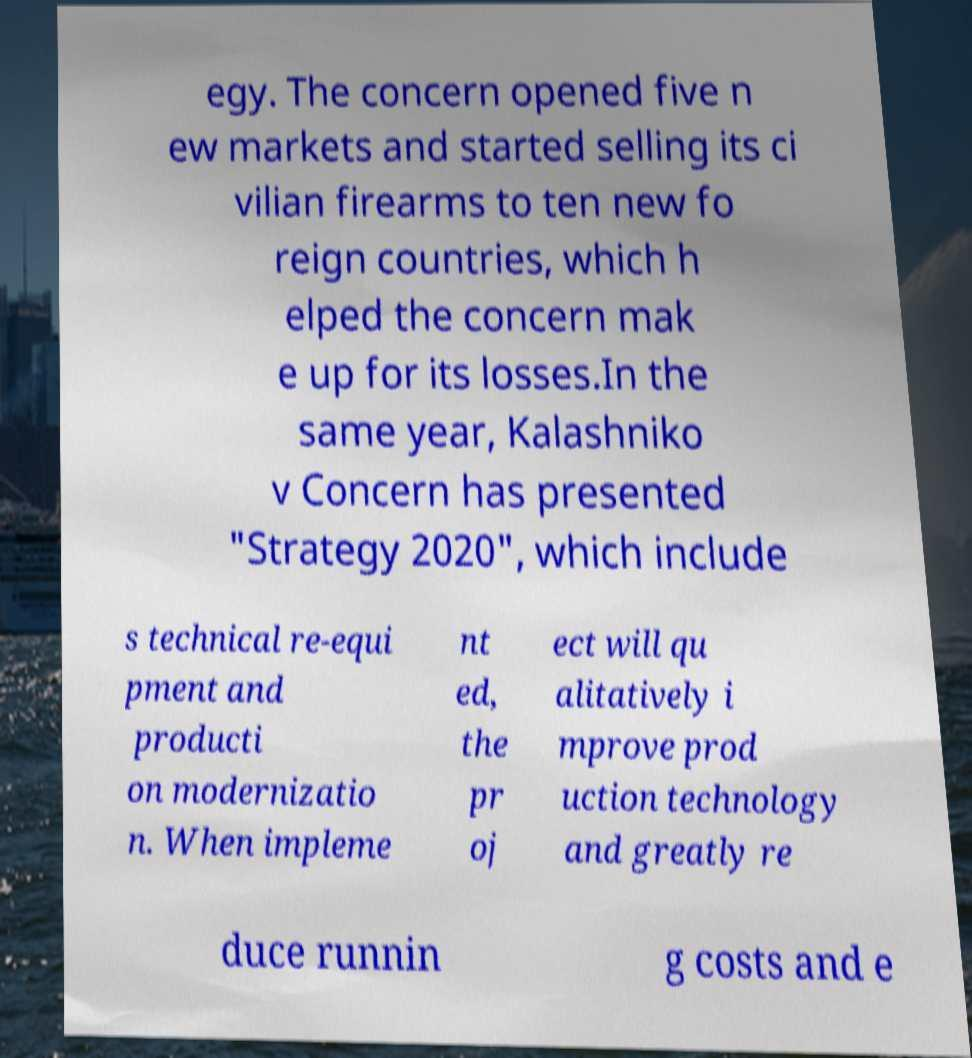Could you assist in decoding the text presented in this image and type it out clearly? egy. The concern opened five n ew markets and started selling its ci vilian firearms to ten new fo reign countries, which h elped the concern mak e up for its losses.In the same year, Kalashniko v Concern has presented "Strategy 2020", which include s technical re-equi pment and producti on modernizatio n. When impleme nt ed, the pr oj ect will qu alitatively i mprove prod uction technology and greatly re duce runnin g costs and e 